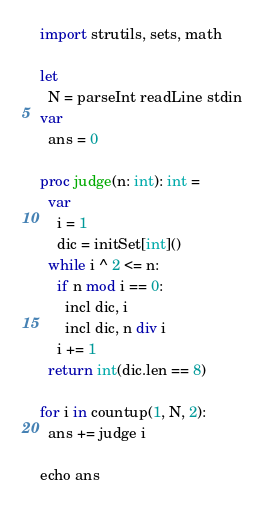Convert code to text. <code><loc_0><loc_0><loc_500><loc_500><_Nim_>import strutils, sets, math

let
  N = parseInt readLine stdin
var
  ans = 0

proc judge(n: int): int =
  var
    i = 1
    dic = initSet[int]()
  while i ^ 2 <= n:
    if n mod i == 0:
      incl dic, i
      incl dic, n div i
    i += 1
  return int(dic.len == 8)

for i in countup(1, N, 2):
  ans += judge i

echo ans
</code> 